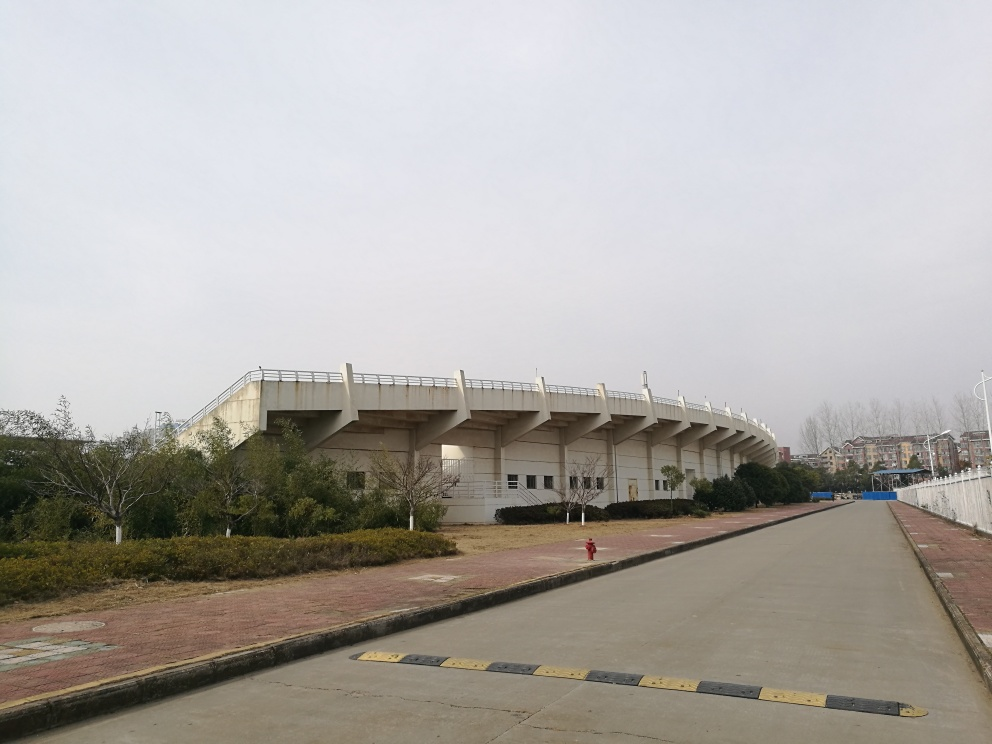Can you comment on the atmosphere conveyed by the image? Does it feel welcoming or deserted? The image conveys a sense of starkness and desertion, emphasized by the absence of people and the overcast sky. The openness of the space and the bare trees contribute to a somewhat unwelcoming and desolate atmosphere, where the silence seems more pronounced. What impact does the weather have on the perception of this image? The grey, overcast weather in the image casts a dreary mood over the scene, muting the colors and perhaps intensifying the feeling of isolation. Such gloomy weather tends to suppress vibrancy and can make spaces that might otherwise seem lively appear more somber and uninviting. 